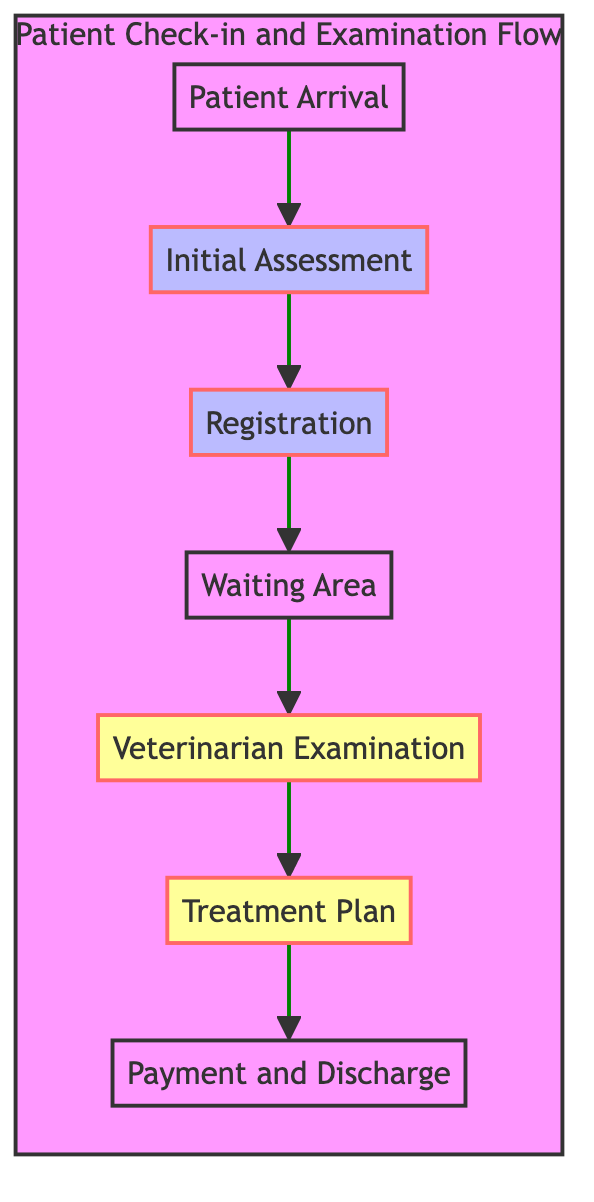What is the first step in the flowchart? The flowchart starts with "Patient Arrival," which indicates it is the initial point in the process.
Answer: Patient Arrival How many nodes are present in the diagram? There are seven nodes, representing different steps in the patient check-in and examination process.
Answer: Seven What actions are performed during the "Initial Assessment"? The actions in the "Initial Assessment" node include weighing the pet and recording temperature and basic vitals, which are part of the health assessment process.
Answer: Weigh the pet, Record temperature and basic vitals Which step directly follows the "Waiting Area"? The "Veterinarian Examination" step directly follows the "Waiting Area," indicating that once waiting is done, the examination takes place next.
Answer: Veterinarian Examination In which step is the treatment plan formulated? The treatment plan is formulated during the "Treatment Plan" step, where the veterinarian prescribes medication and provides care instructions.
Answer: Treatment Plan What type of node is "Veterinarian Examination"? The "Veterinarian Examination" node is classified as a decision node, indicating that this step may involve choices based on examination outcomes and diagnostics.
Answer: Decision What is the last step of the patient process? The final step in the process is "Payment and Discharge," where the payment is processed and the pet is discharged from the clinic.
Answer: Payment and Discharge 